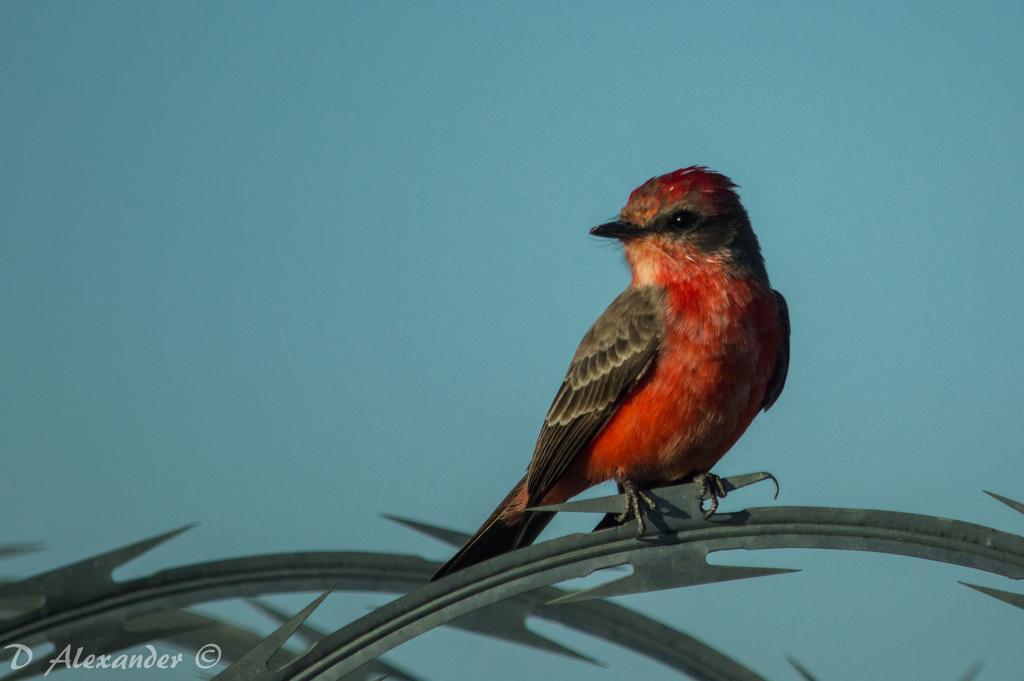In one or two sentences, can you explain what this image depicts? In this image, we can see a bird on the leaf and on the bottom left, there is a text. 